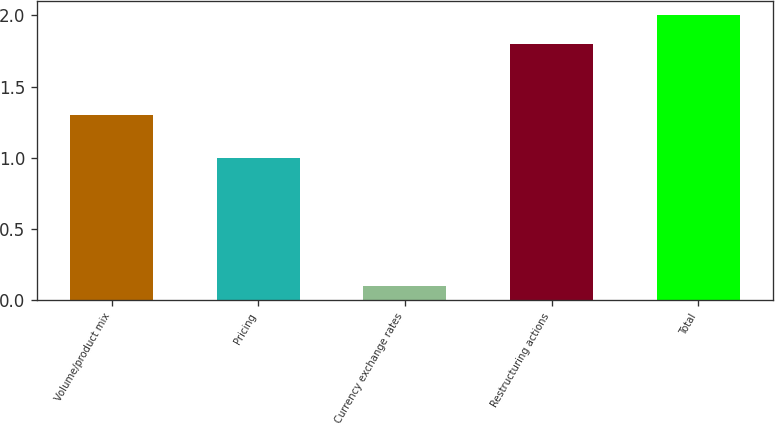Convert chart. <chart><loc_0><loc_0><loc_500><loc_500><bar_chart><fcel>Volume/product mix<fcel>Pricing<fcel>Currency exchange rates<fcel>Restructuring actions<fcel>Total<nl><fcel>1.3<fcel>1<fcel>0.1<fcel>1.8<fcel>2<nl></chart> 